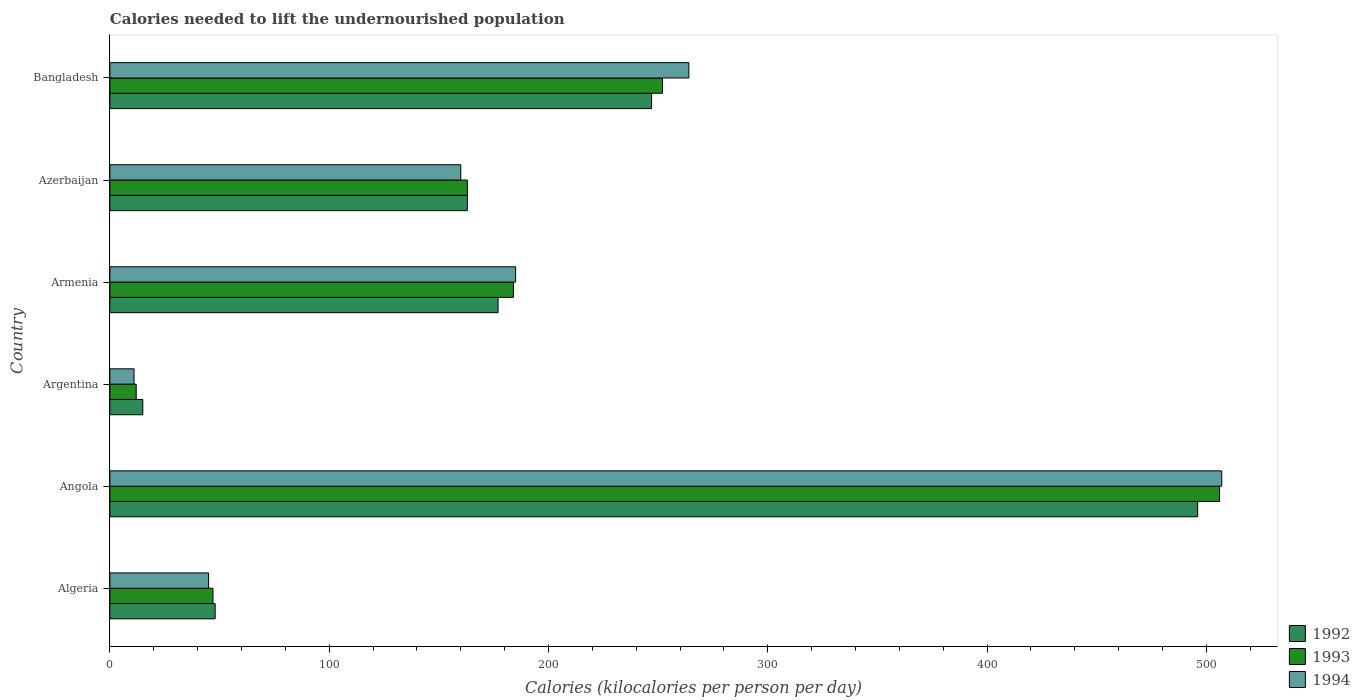How many groups of bars are there?
Offer a terse response. 6. Are the number of bars per tick equal to the number of legend labels?
Provide a succinct answer. Yes. How many bars are there on the 5th tick from the bottom?
Your answer should be compact. 3. What is the label of the 1st group of bars from the top?
Provide a succinct answer. Bangladesh. What is the total calories needed to lift the undernourished population in 1994 in Bangladesh?
Your response must be concise. 264. Across all countries, what is the maximum total calories needed to lift the undernourished population in 1993?
Make the answer very short. 506. In which country was the total calories needed to lift the undernourished population in 1992 maximum?
Your response must be concise. Angola. In which country was the total calories needed to lift the undernourished population in 1992 minimum?
Offer a terse response. Argentina. What is the total total calories needed to lift the undernourished population in 1994 in the graph?
Offer a very short reply. 1172. What is the difference between the total calories needed to lift the undernourished population in 1992 in Armenia and that in Bangladesh?
Give a very brief answer. -70. What is the average total calories needed to lift the undernourished population in 1993 per country?
Keep it short and to the point. 194. What is the difference between the total calories needed to lift the undernourished population in 1994 and total calories needed to lift the undernourished population in 1992 in Azerbaijan?
Ensure brevity in your answer.  -3. In how many countries, is the total calories needed to lift the undernourished population in 1993 greater than 240 kilocalories?
Your answer should be very brief. 2. What is the ratio of the total calories needed to lift the undernourished population in 1992 in Armenia to that in Bangladesh?
Your answer should be very brief. 0.72. What is the difference between the highest and the second highest total calories needed to lift the undernourished population in 1993?
Your answer should be compact. 254. What is the difference between the highest and the lowest total calories needed to lift the undernourished population in 1992?
Provide a short and direct response. 481. In how many countries, is the total calories needed to lift the undernourished population in 1992 greater than the average total calories needed to lift the undernourished population in 1992 taken over all countries?
Provide a short and direct response. 2. Is the sum of the total calories needed to lift the undernourished population in 1992 in Angola and Armenia greater than the maximum total calories needed to lift the undernourished population in 1994 across all countries?
Provide a succinct answer. Yes. What does the 2nd bar from the top in Armenia represents?
Your response must be concise. 1993. What does the 1st bar from the bottom in Bangladesh represents?
Provide a short and direct response. 1992. How many bars are there?
Offer a terse response. 18. How many countries are there in the graph?
Offer a very short reply. 6. Are the values on the major ticks of X-axis written in scientific E-notation?
Provide a short and direct response. No. Does the graph contain grids?
Your answer should be compact. No. Where does the legend appear in the graph?
Offer a terse response. Bottom right. How many legend labels are there?
Provide a succinct answer. 3. What is the title of the graph?
Your response must be concise. Calories needed to lift the undernourished population. Does "1998" appear as one of the legend labels in the graph?
Keep it short and to the point. No. What is the label or title of the X-axis?
Your answer should be compact. Calories (kilocalories per person per day). What is the Calories (kilocalories per person per day) of 1994 in Algeria?
Offer a terse response. 45. What is the Calories (kilocalories per person per day) in 1992 in Angola?
Your response must be concise. 496. What is the Calories (kilocalories per person per day) in 1993 in Angola?
Give a very brief answer. 506. What is the Calories (kilocalories per person per day) in 1994 in Angola?
Give a very brief answer. 507. What is the Calories (kilocalories per person per day) of 1992 in Argentina?
Keep it short and to the point. 15. What is the Calories (kilocalories per person per day) in 1992 in Armenia?
Provide a short and direct response. 177. What is the Calories (kilocalories per person per day) in 1993 in Armenia?
Your answer should be compact. 184. What is the Calories (kilocalories per person per day) in 1994 in Armenia?
Your answer should be very brief. 185. What is the Calories (kilocalories per person per day) of 1992 in Azerbaijan?
Ensure brevity in your answer.  163. What is the Calories (kilocalories per person per day) of 1993 in Azerbaijan?
Provide a succinct answer. 163. What is the Calories (kilocalories per person per day) of 1994 in Azerbaijan?
Keep it short and to the point. 160. What is the Calories (kilocalories per person per day) of 1992 in Bangladesh?
Provide a succinct answer. 247. What is the Calories (kilocalories per person per day) in 1993 in Bangladesh?
Offer a terse response. 252. What is the Calories (kilocalories per person per day) of 1994 in Bangladesh?
Your answer should be very brief. 264. Across all countries, what is the maximum Calories (kilocalories per person per day) in 1992?
Keep it short and to the point. 496. Across all countries, what is the maximum Calories (kilocalories per person per day) of 1993?
Your answer should be compact. 506. Across all countries, what is the maximum Calories (kilocalories per person per day) in 1994?
Keep it short and to the point. 507. Across all countries, what is the minimum Calories (kilocalories per person per day) of 1992?
Your answer should be compact. 15. Across all countries, what is the minimum Calories (kilocalories per person per day) in 1993?
Keep it short and to the point. 12. Across all countries, what is the minimum Calories (kilocalories per person per day) in 1994?
Give a very brief answer. 11. What is the total Calories (kilocalories per person per day) of 1992 in the graph?
Give a very brief answer. 1146. What is the total Calories (kilocalories per person per day) in 1993 in the graph?
Ensure brevity in your answer.  1164. What is the total Calories (kilocalories per person per day) in 1994 in the graph?
Give a very brief answer. 1172. What is the difference between the Calories (kilocalories per person per day) in 1992 in Algeria and that in Angola?
Provide a short and direct response. -448. What is the difference between the Calories (kilocalories per person per day) in 1993 in Algeria and that in Angola?
Give a very brief answer. -459. What is the difference between the Calories (kilocalories per person per day) in 1994 in Algeria and that in Angola?
Offer a terse response. -462. What is the difference between the Calories (kilocalories per person per day) of 1993 in Algeria and that in Argentina?
Your response must be concise. 35. What is the difference between the Calories (kilocalories per person per day) in 1992 in Algeria and that in Armenia?
Provide a short and direct response. -129. What is the difference between the Calories (kilocalories per person per day) in 1993 in Algeria and that in Armenia?
Your answer should be compact. -137. What is the difference between the Calories (kilocalories per person per day) in 1994 in Algeria and that in Armenia?
Your answer should be very brief. -140. What is the difference between the Calories (kilocalories per person per day) of 1992 in Algeria and that in Azerbaijan?
Your response must be concise. -115. What is the difference between the Calories (kilocalories per person per day) in 1993 in Algeria and that in Azerbaijan?
Offer a very short reply. -116. What is the difference between the Calories (kilocalories per person per day) in 1994 in Algeria and that in Azerbaijan?
Give a very brief answer. -115. What is the difference between the Calories (kilocalories per person per day) in 1992 in Algeria and that in Bangladesh?
Make the answer very short. -199. What is the difference between the Calories (kilocalories per person per day) of 1993 in Algeria and that in Bangladesh?
Your answer should be compact. -205. What is the difference between the Calories (kilocalories per person per day) of 1994 in Algeria and that in Bangladesh?
Provide a short and direct response. -219. What is the difference between the Calories (kilocalories per person per day) of 1992 in Angola and that in Argentina?
Provide a succinct answer. 481. What is the difference between the Calories (kilocalories per person per day) of 1993 in Angola and that in Argentina?
Ensure brevity in your answer.  494. What is the difference between the Calories (kilocalories per person per day) of 1994 in Angola and that in Argentina?
Make the answer very short. 496. What is the difference between the Calories (kilocalories per person per day) of 1992 in Angola and that in Armenia?
Provide a short and direct response. 319. What is the difference between the Calories (kilocalories per person per day) of 1993 in Angola and that in Armenia?
Offer a terse response. 322. What is the difference between the Calories (kilocalories per person per day) of 1994 in Angola and that in Armenia?
Make the answer very short. 322. What is the difference between the Calories (kilocalories per person per day) in 1992 in Angola and that in Azerbaijan?
Your answer should be very brief. 333. What is the difference between the Calories (kilocalories per person per day) in 1993 in Angola and that in Azerbaijan?
Keep it short and to the point. 343. What is the difference between the Calories (kilocalories per person per day) in 1994 in Angola and that in Azerbaijan?
Keep it short and to the point. 347. What is the difference between the Calories (kilocalories per person per day) of 1992 in Angola and that in Bangladesh?
Offer a very short reply. 249. What is the difference between the Calories (kilocalories per person per day) of 1993 in Angola and that in Bangladesh?
Your answer should be very brief. 254. What is the difference between the Calories (kilocalories per person per day) in 1994 in Angola and that in Bangladesh?
Provide a short and direct response. 243. What is the difference between the Calories (kilocalories per person per day) in 1992 in Argentina and that in Armenia?
Your answer should be compact. -162. What is the difference between the Calories (kilocalories per person per day) of 1993 in Argentina and that in Armenia?
Your answer should be very brief. -172. What is the difference between the Calories (kilocalories per person per day) of 1994 in Argentina and that in Armenia?
Make the answer very short. -174. What is the difference between the Calories (kilocalories per person per day) of 1992 in Argentina and that in Azerbaijan?
Provide a succinct answer. -148. What is the difference between the Calories (kilocalories per person per day) in 1993 in Argentina and that in Azerbaijan?
Provide a succinct answer. -151. What is the difference between the Calories (kilocalories per person per day) in 1994 in Argentina and that in Azerbaijan?
Provide a succinct answer. -149. What is the difference between the Calories (kilocalories per person per day) of 1992 in Argentina and that in Bangladesh?
Your response must be concise. -232. What is the difference between the Calories (kilocalories per person per day) of 1993 in Argentina and that in Bangladesh?
Offer a very short reply. -240. What is the difference between the Calories (kilocalories per person per day) in 1994 in Argentina and that in Bangladesh?
Make the answer very short. -253. What is the difference between the Calories (kilocalories per person per day) in 1992 in Armenia and that in Azerbaijan?
Offer a very short reply. 14. What is the difference between the Calories (kilocalories per person per day) of 1993 in Armenia and that in Azerbaijan?
Offer a very short reply. 21. What is the difference between the Calories (kilocalories per person per day) of 1992 in Armenia and that in Bangladesh?
Your response must be concise. -70. What is the difference between the Calories (kilocalories per person per day) in 1993 in Armenia and that in Bangladesh?
Your response must be concise. -68. What is the difference between the Calories (kilocalories per person per day) in 1994 in Armenia and that in Bangladesh?
Provide a succinct answer. -79. What is the difference between the Calories (kilocalories per person per day) in 1992 in Azerbaijan and that in Bangladesh?
Provide a succinct answer. -84. What is the difference between the Calories (kilocalories per person per day) of 1993 in Azerbaijan and that in Bangladesh?
Offer a terse response. -89. What is the difference between the Calories (kilocalories per person per day) of 1994 in Azerbaijan and that in Bangladesh?
Offer a very short reply. -104. What is the difference between the Calories (kilocalories per person per day) of 1992 in Algeria and the Calories (kilocalories per person per day) of 1993 in Angola?
Keep it short and to the point. -458. What is the difference between the Calories (kilocalories per person per day) of 1992 in Algeria and the Calories (kilocalories per person per day) of 1994 in Angola?
Your answer should be compact. -459. What is the difference between the Calories (kilocalories per person per day) of 1993 in Algeria and the Calories (kilocalories per person per day) of 1994 in Angola?
Provide a short and direct response. -460. What is the difference between the Calories (kilocalories per person per day) of 1992 in Algeria and the Calories (kilocalories per person per day) of 1994 in Argentina?
Keep it short and to the point. 37. What is the difference between the Calories (kilocalories per person per day) in 1992 in Algeria and the Calories (kilocalories per person per day) in 1993 in Armenia?
Provide a short and direct response. -136. What is the difference between the Calories (kilocalories per person per day) of 1992 in Algeria and the Calories (kilocalories per person per day) of 1994 in Armenia?
Give a very brief answer. -137. What is the difference between the Calories (kilocalories per person per day) in 1993 in Algeria and the Calories (kilocalories per person per day) in 1994 in Armenia?
Your answer should be compact. -138. What is the difference between the Calories (kilocalories per person per day) in 1992 in Algeria and the Calories (kilocalories per person per day) in 1993 in Azerbaijan?
Offer a very short reply. -115. What is the difference between the Calories (kilocalories per person per day) of 1992 in Algeria and the Calories (kilocalories per person per day) of 1994 in Azerbaijan?
Make the answer very short. -112. What is the difference between the Calories (kilocalories per person per day) of 1993 in Algeria and the Calories (kilocalories per person per day) of 1994 in Azerbaijan?
Offer a terse response. -113. What is the difference between the Calories (kilocalories per person per day) of 1992 in Algeria and the Calories (kilocalories per person per day) of 1993 in Bangladesh?
Your response must be concise. -204. What is the difference between the Calories (kilocalories per person per day) of 1992 in Algeria and the Calories (kilocalories per person per day) of 1994 in Bangladesh?
Your answer should be very brief. -216. What is the difference between the Calories (kilocalories per person per day) in 1993 in Algeria and the Calories (kilocalories per person per day) in 1994 in Bangladesh?
Provide a succinct answer. -217. What is the difference between the Calories (kilocalories per person per day) of 1992 in Angola and the Calories (kilocalories per person per day) of 1993 in Argentina?
Provide a short and direct response. 484. What is the difference between the Calories (kilocalories per person per day) of 1992 in Angola and the Calories (kilocalories per person per day) of 1994 in Argentina?
Offer a terse response. 485. What is the difference between the Calories (kilocalories per person per day) of 1993 in Angola and the Calories (kilocalories per person per day) of 1994 in Argentina?
Your answer should be very brief. 495. What is the difference between the Calories (kilocalories per person per day) in 1992 in Angola and the Calories (kilocalories per person per day) in 1993 in Armenia?
Keep it short and to the point. 312. What is the difference between the Calories (kilocalories per person per day) in 1992 in Angola and the Calories (kilocalories per person per day) in 1994 in Armenia?
Offer a very short reply. 311. What is the difference between the Calories (kilocalories per person per day) in 1993 in Angola and the Calories (kilocalories per person per day) in 1994 in Armenia?
Your answer should be very brief. 321. What is the difference between the Calories (kilocalories per person per day) of 1992 in Angola and the Calories (kilocalories per person per day) of 1993 in Azerbaijan?
Offer a terse response. 333. What is the difference between the Calories (kilocalories per person per day) of 1992 in Angola and the Calories (kilocalories per person per day) of 1994 in Azerbaijan?
Offer a very short reply. 336. What is the difference between the Calories (kilocalories per person per day) in 1993 in Angola and the Calories (kilocalories per person per day) in 1994 in Azerbaijan?
Make the answer very short. 346. What is the difference between the Calories (kilocalories per person per day) in 1992 in Angola and the Calories (kilocalories per person per day) in 1993 in Bangladesh?
Give a very brief answer. 244. What is the difference between the Calories (kilocalories per person per day) of 1992 in Angola and the Calories (kilocalories per person per day) of 1994 in Bangladesh?
Keep it short and to the point. 232. What is the difference between the Calories (kilocalories per person per day) in 1993 in Angola and the Calories (kilocalories per person per day) in 1994 in Bangladesh?
Your answer should be compact. 242. What is the difference between the Calories (kilocalories per person per day) in 1992 in Argentina and the Calories (kilocalories per person per day) in 1993 in Armenia?
Your answer should be very brief. -169. What is the difference between the Calories (kilocalories per person per day) of 1992 in Argentina and the Calories (kilocalories per person per day) of 1994 in Armenia?
Provide a succinct answer. -170. What is the difference between the Calories (kilocalories per person per day) in 1993 in Argentina and the Calories (kilocalories per person per day) in 1994 in Armenia?
Ensure brevity in your answer.  -173. What is the difference between the Calories (kilocalories per person per day) in 1992 in Argentina and the Calories (kilocalories per person per day) in 1993 in Azerbaijan?
Your answer should be very brief. -148. What is the difference between the Calories (kilocalories per person per day) of 1992 in Argentina and the Calories (kilocalories per person per day) of 1994 in Azerbaijan?
Keep it short and to the point. -145. What is the difference between the Calories (kilocalories per person per day) of 1993 in Argentina and the Calories (kilocalories per person per day) of 1994 in Azerbaijan?
Your answer should be very brief. -148. What is the difference between the Calories (kilocalories per person per day) of 1992 in Argentina and the Calories (kilocalories per person per day) of 1993 in Bangladesh?
Ensure brevity in your answer.  -237. What is the difference between the Calories (kilocalories per person per day) in 1992 in Argentina and the Calories (kilocalories per person per day) in 1994 in Bangladesh?
Offer a terse response. -249. What is the difference between the Calories (kilocalories per person per day) of 1993 in Argentina and the Calories (kilocalories per person per day) of 1994 in Bangladesh?
Ensure brevity in your answer.  -252. What is the difference between the Calories (kilocalories per person per day) of 1992 in Armenia and the Calories (kilocalories per person per day) of 1993 in Azerbaijan?
Make the answer very short. 14. What is the difference between the Calories (kilocalories per person per day) of 1992 in Armenia and the Calories (kilocalories per person per day) of 1994 in Azerbaijan?
Your answer should be compact. 17. What is the difference between the Calories (kilocalories per person per day) in 1993 in Armenia and the Calories (kilocalories per person per day) in 1994 in Azerbaijan?
Provide a succinct answer. 24. What is the difference between the Calories (kilocalories per person per day) of 1992 in Armenia and the Calories (kilocalories per person per day) of 1993 in Bangladesh?
Make the answer very short. -75. What is the difference between the Calories (kilocalories per person per day) in 1992 in Armenia and the Calories (kilocalories per person per day) in 1994 in Bangladesh?
Ensure brevity in your answer.  -87. What is the difference between the Calories (kilocalories per person per day) in 1993 in Armenia and the Calories (kilocalories per person per day) in 1994 in Bangladesh?
Offer a very short reply. -80. What is the difference between the Calories (kilocalories per person per day) of 1992 in Azerbaijan and the Calories (kilocalories per person per day) of 1993 in Bangladesh?
Your response must be concise. -89. What is the difference between the Calories (kilocalories per person per day) of 1992 in Azerbaijan and the Calories (kilocalories per person per day) of 1994 in Bangladesh?
Offer a terse response. -101. What is the difference between the Calories (kilocalories per person per day) in 1993 in Azerbaijan and the Calories (kilocalories per person per day) in 1994 in Bangladesh?
Give a very brief answer. -101. What is the average Calories (kilocalories per person per day) in 1992 per country?
Offer a very short reply. 191. What is the average Calories (kilocalories per person per day) in 1993 per country?
Ensure brevity in your answer.  194. What is the average Calories (kilocalories per person per day) of 1994 per country?
Offer a very short reply. 195.33. What is the difference between the Calories (kilocalories per person per day) of 1992 and Calories (kilocalories per person per day) of 1993 in Algeria?
Offer a terse response. 1. What is the difference between the Calories (kilocalories per person per day) in 1993 and Calories (kilocalories per person per day) in 1994 in Algeria?
Provide a short and direct response. 2. What is the difference between the Calories (kilocalories per person per day) in 1992 and Calories (kilocalories per person per day) in 1994 in Angola?
Keep it short and to the point. -11. What is the difference between the Calories (kilocalories per person per day) of 1993 and Calories (kilocalories per person per day) of 1994 in Angola?
Give a very brief answer. -1. What is the difference between the Calories (kilocalories per person per day) in 1992 and Calories (kilocalories per person per day) in 1993 in Argentina?
Keep it short and to the point. 3. What is the difference between the Calories (kilocalories per person per day) of 1992 and Calories (kilocalories per person per day) of 1994 in Argentina?
Provide a short and direct response. 4. What is the difference between the Calories (kilocalories per person per day) of 1993 and Calories (kilocalories per person per day) of 1994 in Argentina?
Keep it short and to the point. 1. What is the difference between the Calories (kilocalories per person per day) in 1992 and Calories (kilocalories per person per day) in 1993 in Armenia?
Your answer should be compact. -7. What is the difference between the Calories (kilocalories per person per day) in 1993 and Calories (kilocalories per person per day) in 1994 in Azerbaijan?
Offer a terse response. 3. What is the ratio of the Calories (kilocalories per person per day) of 1992 in Algeria to that in Angola?
Make the answer very short. 0.1. What is the ratio of the Calories (kilocalories per person per day) in 1993 in Algeria to that in Angola?
Offer a terse response. 0.09. What is the ratio of the Calories (kilocalories per person per day) in 1994 in Algeria to that in Angola?
Provide a succinct answer. 0.09. What is the ratio of the Calories (kilocalories per person per day) of 1993 in Algeria to that in Argentina?
Keep it short and to the point. 3.92. What is the ratio of the Calories (kilocalories per person per day) in 1994 in Algeria to that in Argentina?
Offer a terse response. 4.09. What is the ratio of the Calories (kilocalories per person per day) in 1992 in Algeria to that in Armenia?
Your response must be concise. 0.27. What is the ratio of the Calories (kilocalories per person per day) of 1993 in Algeria to that in Armenia?
Give a very brief answer. 0.26. What is the ratio of the Calories (kilocalories per person per day) of 1994 in Algeria to that in Armenia?
Keep it short and to the point. 0.24. What is the ratio of the Calories (kilocalories per person per day) in 1992 in Algeria to that in Azerbaijan?
Your answer should be compact. 0.29. What is the ratio of the Calories (kilocalories per person per day) in 1993 in Algeria to that in Azerbaijan?
Offer a terse response. 0.29. What is the ratio of the Calories (kilocalories per person per day) in 1994 in Algeria to that in Azerbaijan?
Your answer should be compact. 0.28. What is the ratio of the Calories (kilocalories per person per day) of 1992 in Algeria to that in Bangladesh?
Ensure brevity in your answer.  0.19. What is the ratio of the Calories (kilocalories per person per day) of 1993 in Algeria to that in Bangladesh?
Your answer should be very brief. 0.19. What is the ratio of the Calories (kilocalories per person per day) of 1994 in Algeria to that in Bangladesh?
Ensure brevity in your answer.  0.17. What is the ratio of the Calories (kilocalories per person per day) in 1992 in Angola to that in Argentina?
Offer a very short reply. 33.07. What is the ratio of the Calories (kilocalories per person per day) in 1993 in Angola to that in Argentina?
Your answer should be very brief. 42.17. What is the ratio of the Calories (kilocalories per person per day) in 1994 in Angola to that in Argentina?
Keep it short and to the point. 46.09. What is the ratio of the Calories (kilocalories per person per day) of 1992 in Angola to that in Armenia?
Your answer should be compact. 2.8. What is the ratio of the Calories (kilocalories per person per day) of 1993 in Angola to that in Armenia?
Provide a short and direct response. 2.75. What is the ratio of the Calories (kilocalories per person per day) in 1994 in Angola to that in Armenia?
Ensure brevity in your answer.  2.74. What is the ratio of the Calories (kilocalories per person per day) in 1992 in Angola to that in Azerbaijan?
Your response must be concise. 3.04. What is the ratio of the Calories (kilocalories per person per day) of 1993 in Angola to that in Azerbaijan?
Offer a very short reply. 3.1. What is the ratio of the Calories (kilocalories per person per day) in 1994 in Angola to that in Azerbaijan?
Offer a very short reply. 3.17. What is the ratio of the Calories (kilocalories per person per day) in 1992 in Angola to that in Bangladesh?
Your response must be concise. 2.01. What is the ratio of the Calories (kilocalories per person per day) of 1993 in Angola to that in Bangladesh?
Keep it short and to the point. 2.01. What is the ratio of the Calories (kilocalories per person per day) in 1994 in Angola to that in Bangladesh?
Make the answer very short. 1.92. What is the ratio of the Calories (kilocalories per person per day) in 1992 in Argentina to that in Armenia?
Offer a very short reply. 0.08. What is the ratio of the Calories (kilocalories per person per day) of 1993 in Argentina to that in Armenia?
Keep it short and to the point. 0.07. What is the ratio of the Calories (kilocalories per person per day) of 1994 in Argentina to that in Armenia?
Your answer should be compact. 0.06. What is the ratio of the Calories (kilocalories per person per day) of 1992 in Argentina to that in Azerbaijan?
Ensure brevity in your answer.  0.09. What is the ratio of the Calories (kilocalories per person per day) in 1993 in Argentina to that in Azerbaijan?
Ensure brevity in your answer.  0.07. What is the ratio of the Calories (kilocalories per person per day) in 1994 in Argentina to that in Azerbaijan?
Offer a terse response. 0.07. What is the ratio of the Calories (kilocalories per person per day) of 1992 in Argentina to that in Bangladesh?
Provide a short and direct response. 0.06. What is the ratio of the Calories (kilocalories per person per day) in 1993 in Argentina to that in Bangladesh?
Your response must be concise. 0.05. What is the ratio of the Calories (kilocalories per person per day) in 1994 in Argentina to that in Bangladesh?
Give a very brief answer. 0.04. What is the ratio of the Calories (kilocalories per person per day) of 1992 in Armenia to that in Azerbaijan?
Offer a terse response. 1.09. What is the ratio of the Calories (kilocalories per person per day) of 1993 in Armenia to that in Azerbaijan?
Your answer should be compact. 1.13. What is the ratio of the Calories (kilocalories per person per day) of 1994 in Armenia to that in Azerbaijan?
Make the answer very short. 1.16. What is the ratio of the Calories (kilocalories per person per day) in 1992 in Armenia to that in Bangladesh?
Give a very brief answer. 0.72. What is the ratio of the Calories (kilocalories per person per day) of 1993 in Armenia to that in Bangladesh?
Ensure brevity in your answer.  0.73. What is the ratio of the Calories (kilocalories per person per day) of 1994 in Armenia to that in Bangladesh?
Offer a terse response. 0.7. What is the ratio of the Calories (kilocalories per person per day) in 1992 in Azerbaijan to that in Bangladesh?
Ensure brevity in your answer.  0.66. What is the ratio of the Calories (kilocalories per person per day) in 1993 in Azerbaijan to that in Bangladesh?
Make the answer very short. 0.65. What is the ratio of the Calories (kilocalories per person per day) of 1994 in Azerbaijan to that in Bangladesh?
Provide a short and direct response. 0.61. What is the difference between the highest and the second highest Calories (kilocalories per person per day) of 1992?
Keep it short and to the point. 249. What is the difference between the highest and the second highest Calories (kilocalories per person per day) of 1993?
Your answer should be very brief. 254. What is the difference between the highest and the second highest Calories (kilocalories per person per day) in 1994?
Give a very brief answer. 243. What is the difference between the highest and the lowest Calories (kilocalories per person per day) of 1992?
Keep it short and to the point. 481. What is the difference between the highest and the lowest Calories (kilocalories per person per day) in 1993?
Keep it short and to the point. 494. What is the difference between the highest and the lowest Calories (kilocalories per person per day) in 1994?
Keep it short and to the point. 496. 